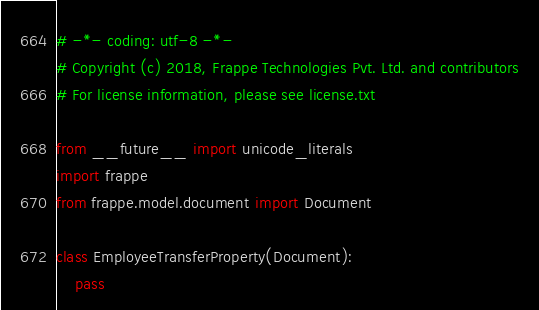<code> <loc_0><loc_0><loc_500><loc_500><_Python_># -*- coding: utf-8 -*-
# Copyright (c) 2018, Frappe Technologies Pvt. Ltd. and contributors
# For license information, please see license.txt

from __future__ import unicode_literals
import frappe
from frappe.model.document import Document

class EmployeeTransferProperty(Document):
	pass
</code> 